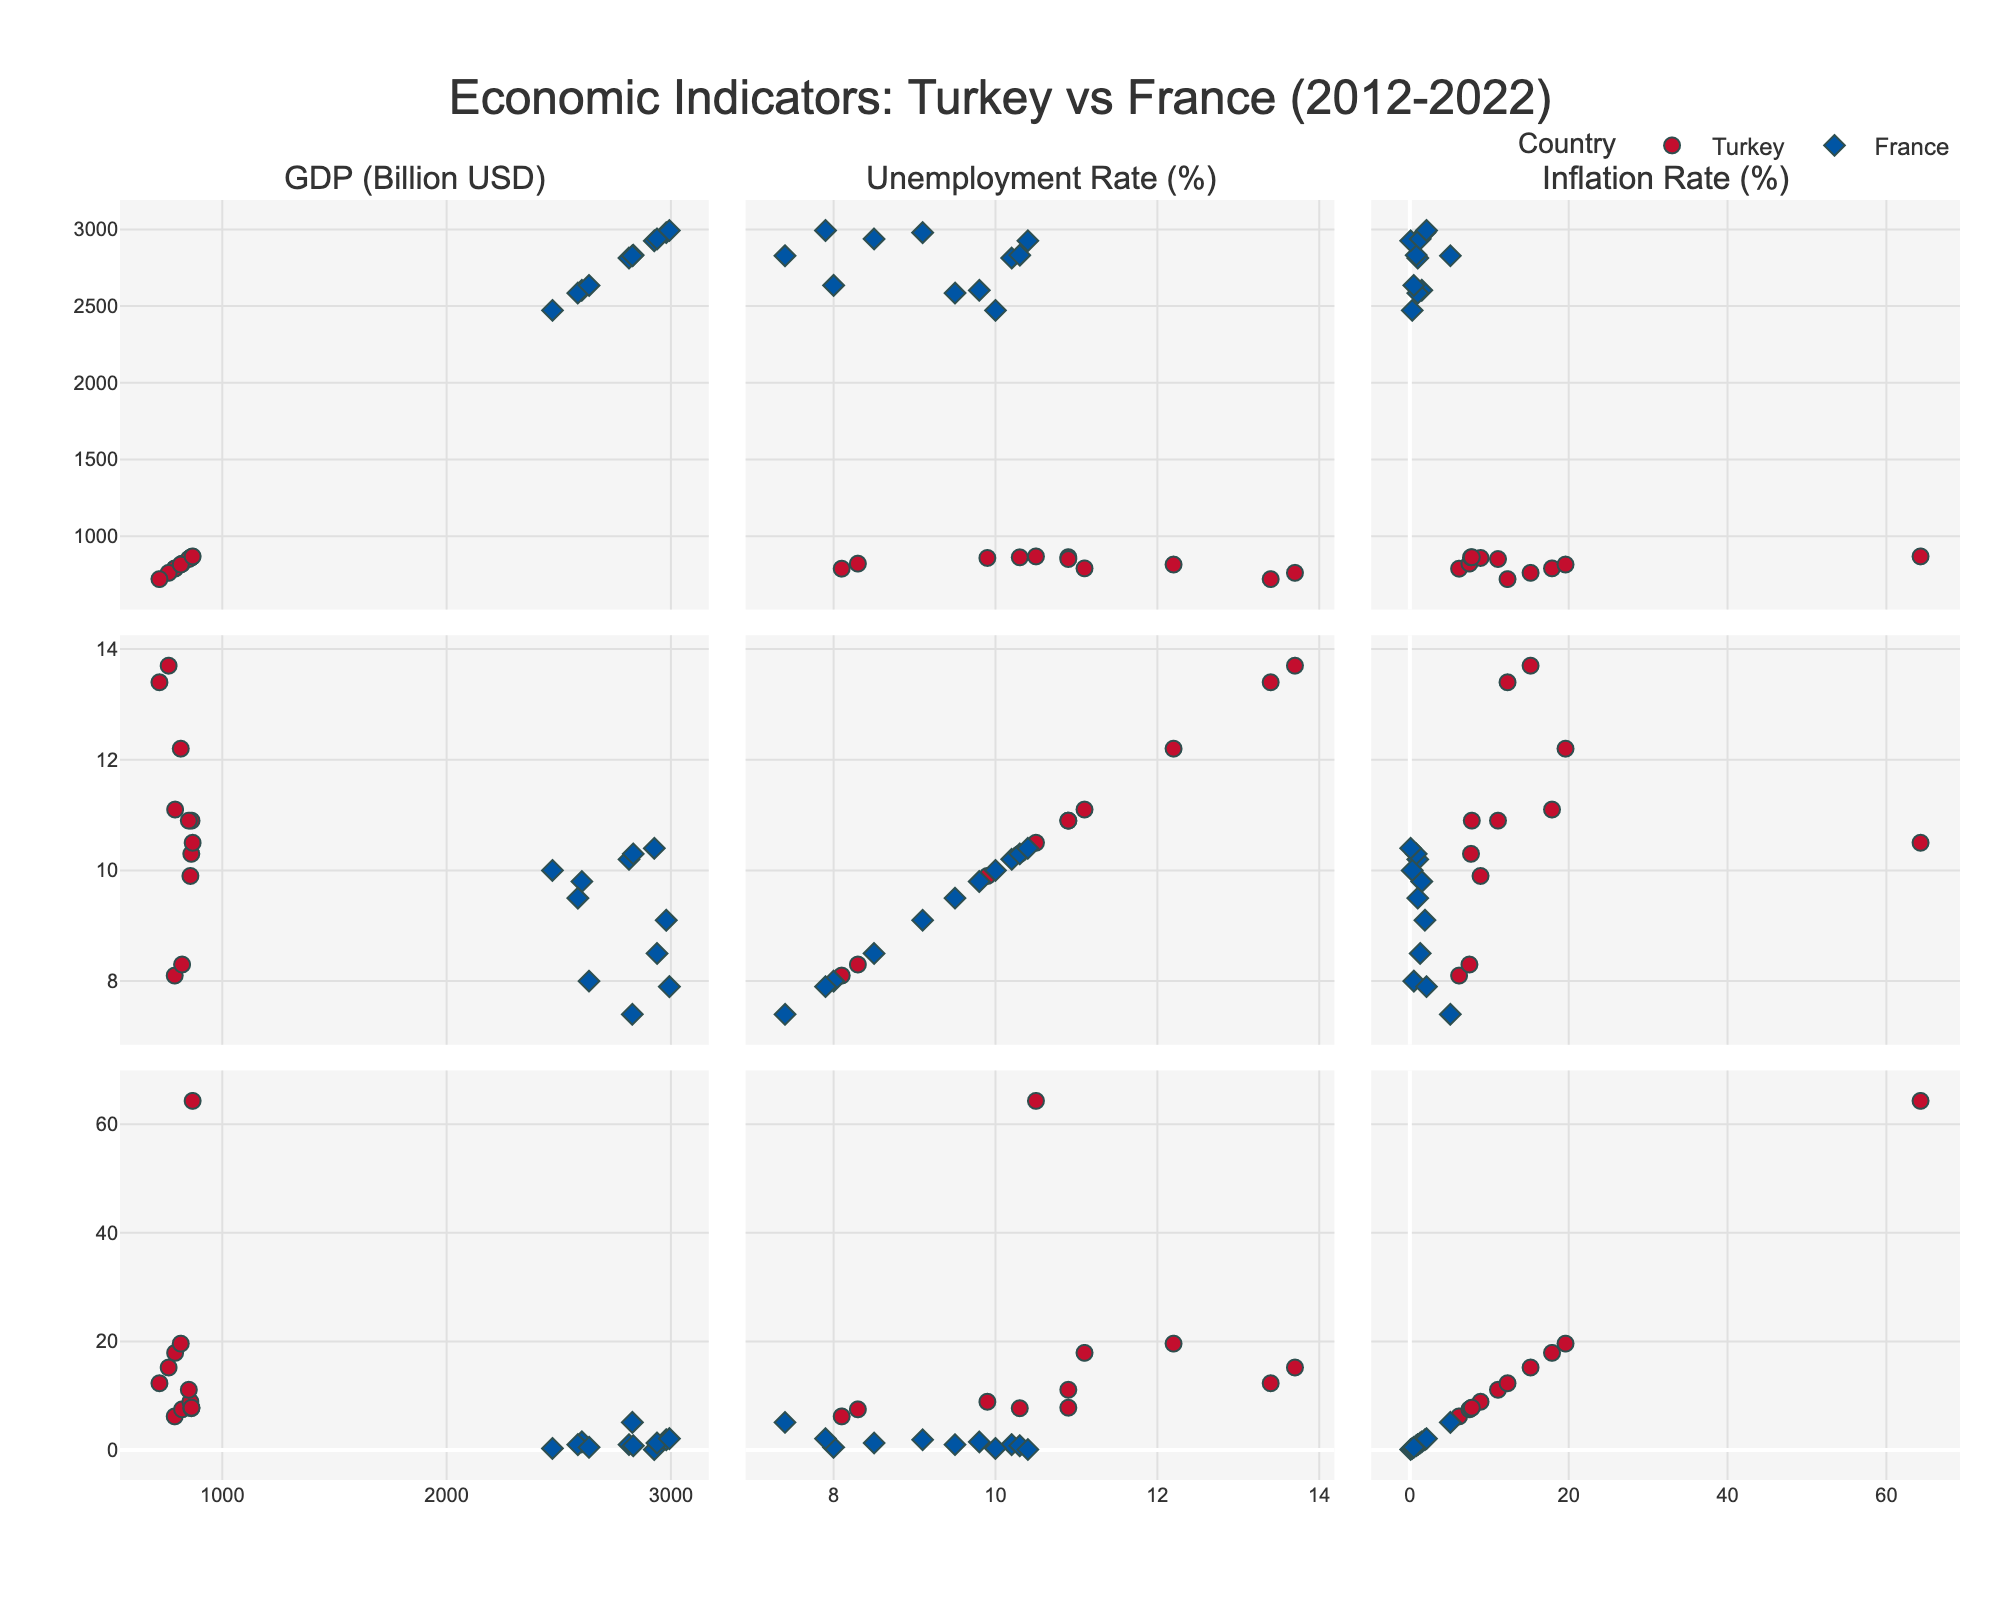what's the title of the figure? The title is at the top of the scatter plot matrix and reads "Economic Indicators: Turkey vs France (2012-2022)".
Answer: Economic Indicators: Turkey vs France (2012-2022) how many subplots are there in the figure? The scatter plot matrix consists of 3 rows and 3 columns of subplots, making a total of 9 subplots.
Answer: 9 what colors represent Turkey and France in the scatter plots? Turkey's points are marked with red color, and France's points are marked with blue color.
Answer: Turkey: red, France: blue which country had higher inflation rates in 2018? By observing the subplots involving the "Inflation Rate (%)" axis, Turkey's inflation rate is significantly higher than France's in 2018.
Answer: Turkey what trend can you observe about France's GDP over the years? France's GDP tends to fluctuate but remains relatively stable compared to Turkey's GDP across the subplots involving GDP on either axis.
Answer: Stable in which years did Turkey have a GDP greater than 800 billion USD? By observing the trend in subplots involving "GDP (Billion USD)" for Turkey, the years with GDP greater than 800 billion USD are 2013, 2014, 2015, 2016, 2021, and 2022.
Answer: 2013, 2014, 2015, 2016, 2021, 2022 compare the unemployment rates of Turkey and France in 2020. Referring to the subplot involving "Unemployment Rate (%)", Turkey's unemployment rate in 2020 is higher than France's.
Answer: Turkey > France what is the relationship between GDP and inflation rates for Turkey? In the scatter plot subplots cross-referencing "GDP (Billion USD)" and "Inflation Rate (%)" for Turkey, there appears to be an inverse relationship: as GDP drops, inflation rates for Turkey increase significantly.
Answer: Inverse relationship did France have any years with an inflation rate higher than 3%? Observing the "Inflation Rate (%)" subplots for France, there are no points above 3%, indicating it never had an inflation rate higher than 3% over the given period.
Answer: No how did the GDP of Turkey change between 2020 and 2022? The GDP of Turkey increased from 720 billion USD in 2020 to 868 billion USD in 2022, as indicated in the subplots involving "GDP (Billion USD)".
Answer: Increased 